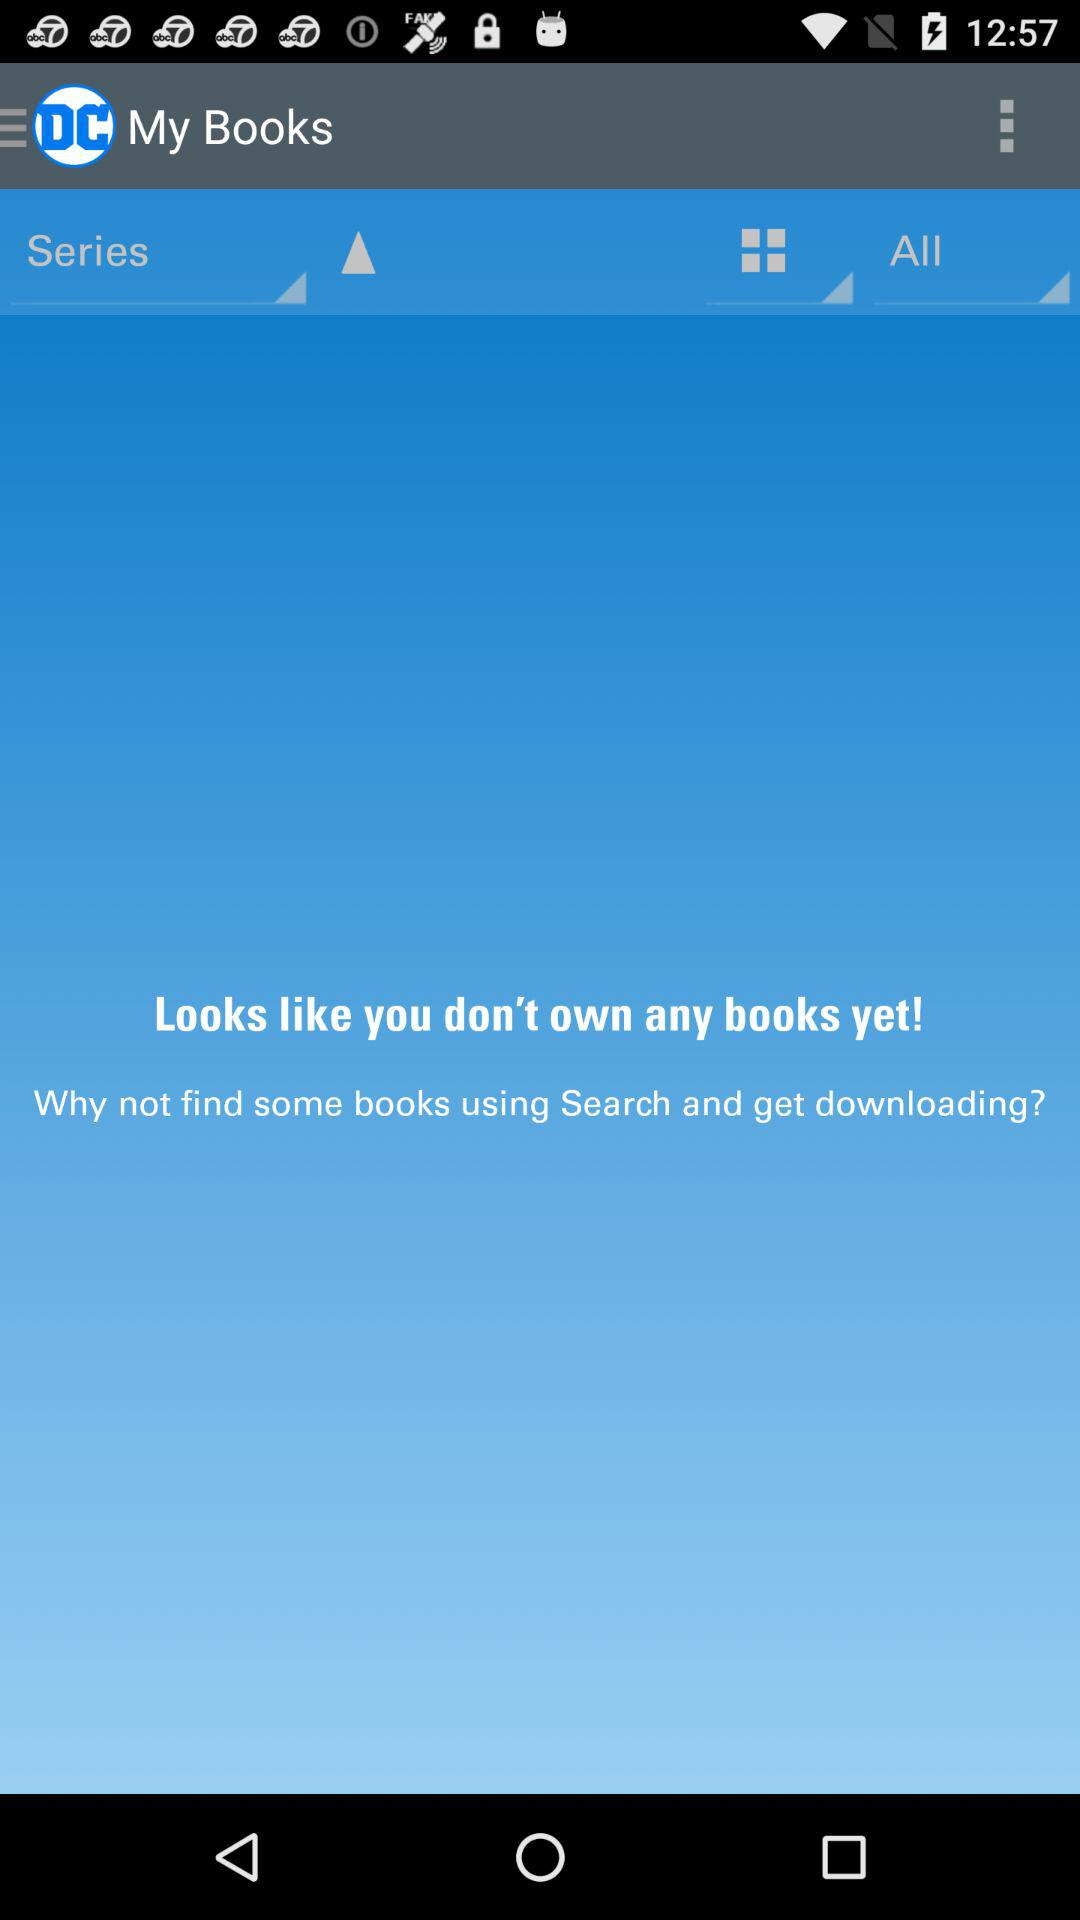Are there any books? There are no books. 